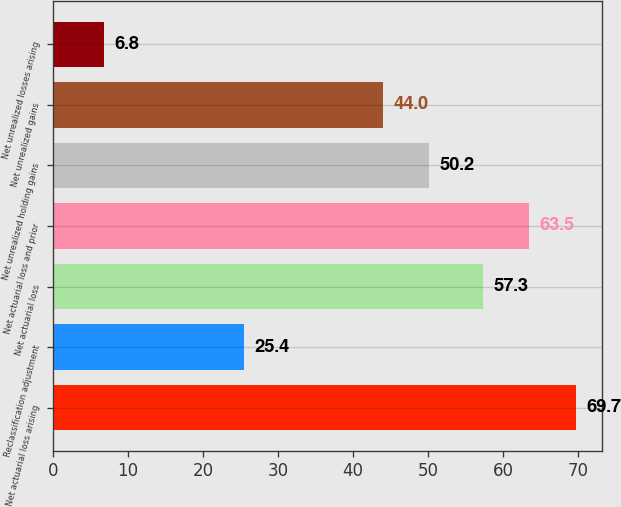Convert chart. <chart><loc_0><loc_0><loc_500><loc_500><bar_chart><fcel>Net actuarial loss arising<fcel>Reclassification adjustment<fcel>Net actuarial loss<fcel>Net actuarial loss and prior<fcel>Net unrealized holding gains<fcel>Net unrealized gains<fcel>Net unrealized losses arising<nl><fcel>69.7<fcel>25.4<fcel>57.3<fcel>63.5<fcel>50.2<fcel>44<fcel>6.8<nl></chart> 